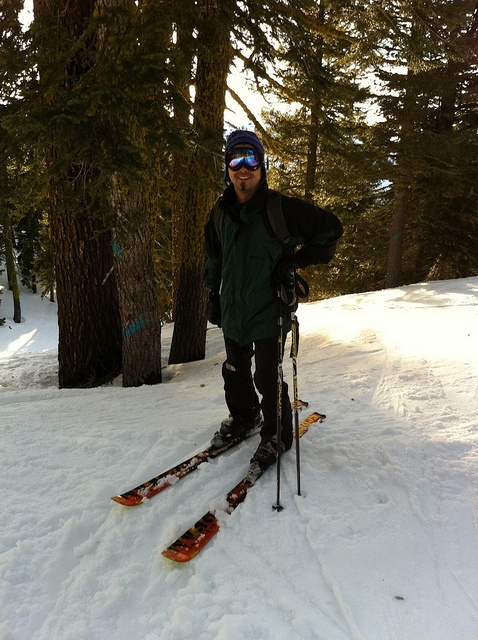Describe the objects in this image and their specific colors. I can see people in maroon, black, gray, and darkgray tones and skis in maroon, black, darkgray, and gray tones in this image. 